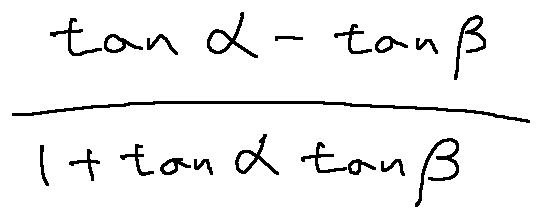Convert formula to latex. <formula><loc_0><loc_0><loc_500><loc_500>\frac { \tan \alpha - \tan \beta } { 1 + \tan \alpha \tan \beta }</formula> 